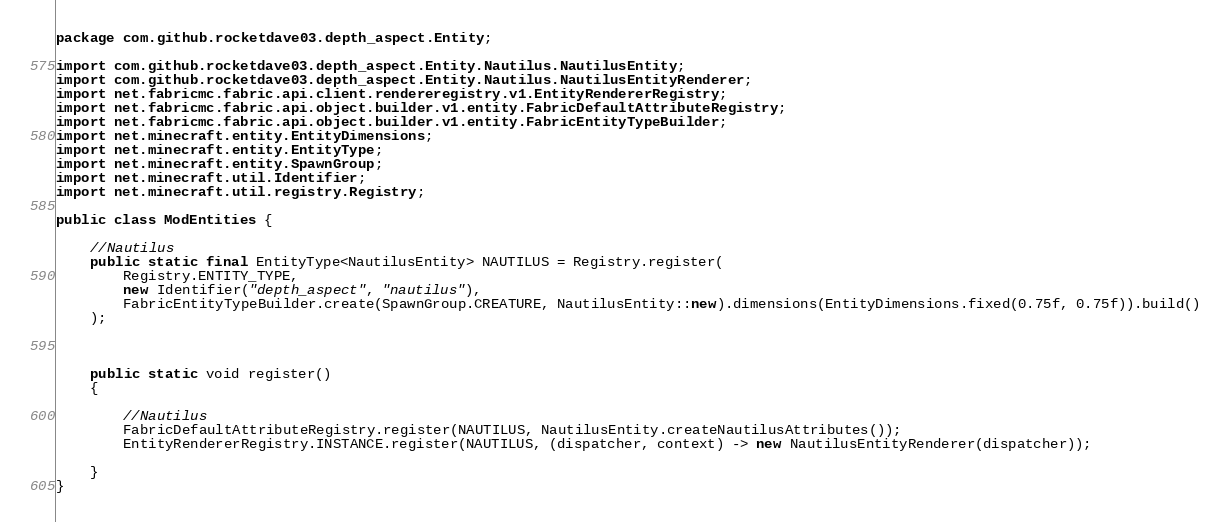Convert code to text. <code><loc_0><loc_0><loc_500><loc_500><_Java_>package com.github.rocketdave03.depth_aspect.Entity;

import com.github.rocketdave03.depth_aspect.Entity.Nautilus.NautilusEntity;
import com.github.rocketdave03.depth_aspect.Entity.Nautilus.NautilusEntityRenderer;
import net.fabricmc.fabric.api.client.rendereregistry.v1.EntityRendererRegistry;
import net.fabricmc.fabric.api.object.builder.v1.entity.FabricDefaultAttributeRegistry;
import net.fabricmc.fabric.api.object.builder.v1.entity.FabricEntityTypeBuilder;
import net.minecraft.entity.EntityDimensions;
import net.minecraft.entity.EntityType;
import net.minecraft.entity.SpawnGroup;
import net.minecraft.util.Identifier;
import net.minecraft.util.registry.Registry;

public class ModEntities {

	//Nautilus
	public static final EntityType<NautilusEntity> NAUTILUS = Registry.register(
		Registry.ENTITY_TYPE,
		new Identifier("depth_aspect", "nautilus"),
		FabricEntityTypeBuilder.create(SpawnGroup.CREATURE, NautilusEntity::new).dimensions(EntityDimensions.fixed(0.75f, 0.75f)).build()
	);



	public static void register()
	{

		//Nautilus
		FabricDefaultAttributeRegistry.register(NAUTILUS, NautilusEntity.createNautilusAttributes());
		EntityRendererRegistry.INSTANCE.register(NAUTILUS, (dispatcher, context) -> new NautilusEntityRenderer(dispatcher));

	}
}
</code> 